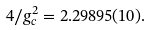<formula> <loc_0><loc_0><loc_500><loc_500>4 / g _ { c } ^ { 2 } = 2 . 2 9 8 9 5 ( 1 0 ) .</formula> 